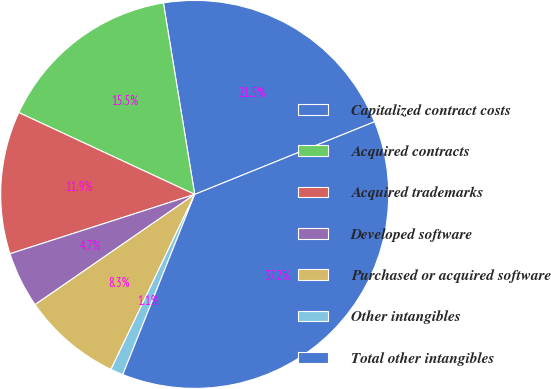Convert chart to OTSL. <chart><loc_0><loc_0><loc_500><loc_500><pie_chart><fcel>Capitalized contract costs<fcel>Acquired contracts<fcel>Acquired trademarks<fcel>Developed software<fcel>Purchased or acquired software<fcel>Other intangibles<fcel>Total other intangibles<nl><fcel>21.47%<fcel>15.49%<fcel>11.88%<fcel>4.67%<fcel>8.28%<fcel>1.06%<fcel>37.15%<nl></chart> 